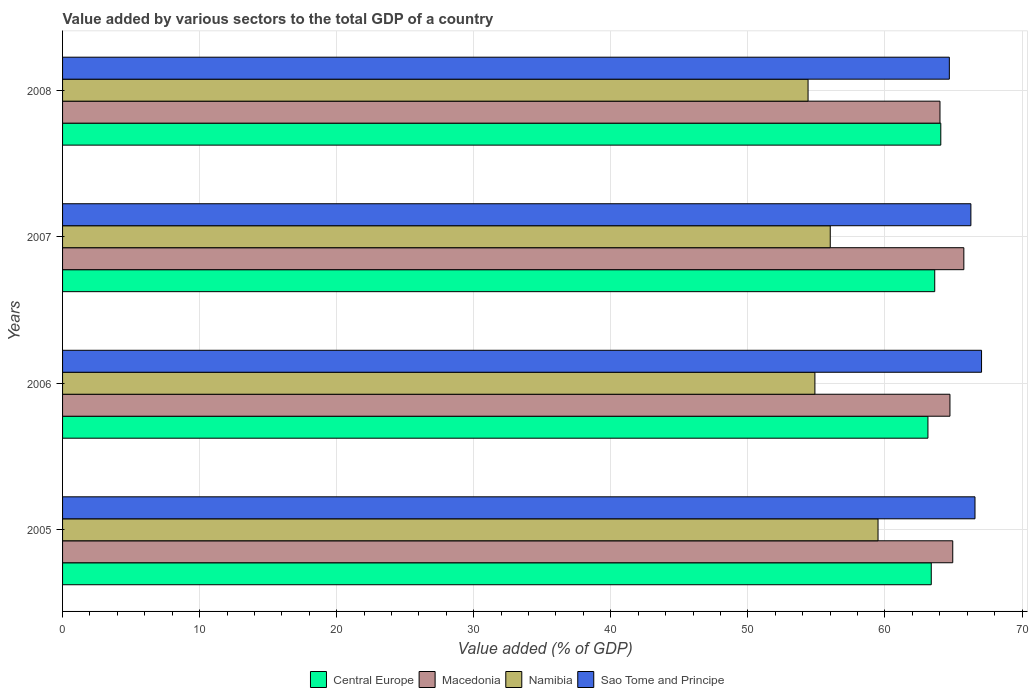Are the number of bars on each tick of the Y-axis equal?
Give a very brief answer. Yes. How many bars are there on the 1st tick from the top?
Your response must be concise. 4. How many bars are there on the 4th tick from the bottom?
Your response must be concise. 4. In how many cases, is the number of bars for a given year not equal to the number of legend labels?
Offer a very short reply. 0. What is the value added by various sectors to the total GDP in Namibia in 2006?
Offer a terse response. 54.89. Across all years, what is the maximum value added by various sectors to the total GDP in Sao Tome and Principe?
Give a very brief answer. 67.05. Across all years, what is the minimum value added by various sectors to the total GDP in Central Europe?
Your answer should be compact. 63.14. In which year was the value added by various sectors to the total GDP in Sao Tome and Principe maximum?
Offer a very short reply. 2006. In which year was the value added by various sectors to the total GDP in Sao Tome and Principe minimum?
Your answer should be compact. 2008. What is the total value added by various sectors to the total GDP in Namibia in the graph?
Make the answer very short. 224.79. What is the difference between the value added by various sectors to the total GDP in Sao Tome and Principe in 2006 and that in 2008?
Keep it short and to the point. 2.35. What is the difference between the value added by various sectors to the total GDP in Macedonia in 2006 and the value added by various sectors to the total GDP in Namibia in 2005?
Make the answer very short. 5.25. What is the average value added by various sectors to the total GDP in Macedonia per year?
Give a very brief answer. 64.87. In the year 2007, what is the difference between the value added by various sectors to the total GDP in Macedonia and value added by various sectors to the total GDP in Central Europe?
Your answer should be compact. 2.12. In how many years, is the value added by various sectors to the total GDP in Macedonia greater than 56 %?
Your response must be concise. 4. What is the ratio of the value added by various sectors to the total GDP in Namibia in 2005 to that in 2008?
Your answer should be very brief. 1.09. Is the value added by various sectors to the total GDP in Central Europe in 2005 less than that in 2007?
Provide a short and direct response. Yes. Is the difference between the value added by various sectors to the total GDP in Macedonia in 2005 and 2006 greater than the difference between the value added by various sectors to the total GDP in Central Europe in 2005 and 2006?
Give a very brief answer. No. What is the difference between the highest and the second highest value added by various sectors to the total GDP in Central Europe?
Your response must be concise. 0.44. What is the difference between the highest and the lowest value added by various sectors to the total GDP in Central Europe?
Your answer should be very brief. 0.94. In how many years, is the value added by various sectors to the total GDP in Macedonia greater than the average value added by various sectors to the total GDP in Macedonia taken over all years?
Provide a short and direct response. 2. Is the sum of the value added by various sectors to the total GDP in Sao Tome and Principe in 2005 and 2006 greater than the maximum value added by various sectors to the total GDP in Macedonia across all years?
Ensure brevity in your answer.  Yes. Is it the case that in every year, the sum of the value added by various sectors to the total GDP in Central Europe and value added by various sectors to the total GDP in Macedonia is greater than the sum of value added by various sectors to the total GDP in Sao Tome and Principe and value added by various sectors to the total GDP in Namibia?
Give a very brief answer. Yes. What does the 1st bar from the top in 2006 represents?
Ensure brevity in your answer.  Sao Tome and Principe. What does the 2nd bar from the bottom in 2006 represents?
Make the answer very short. Macedonia. How many bars are there?
Offer a terse response. 16. Are the values on the major ticks of X-axis written in scientific E-notation?
Ensure brevity in your answer.  No. Where does the legend appear in the graph?
Make the answer very short. Bottom center. How many legend labels are there?
Offer a very short reply. 4. What is the title of the graph?
Offer a very short reply. Value added by various sectors to the total GDP of a country. Does "Slovenia" appear as one of the legend labels in the graph?
Make the answer very short. No. What is the label or title of the X-axis?
Provide a short and direct response. Value added (% of GDP). What is the Value added (% of GDP) of Central Europe in 2005?
Your response must be concise. 63.38. What is the Value added (% of GDP) of Macedonia in 2005?
Your answer should be very brief. 64.95. What is the Value added (% of GDP) in Namibia in 2005?
Make the answer very short. 59.5. What is the Value added (% of GDP) in Sao Tome and Principe in 2005?
Offer a terse response. 66.57. What is the Value added (% of GDP) in Central Europe in 2006?
Ensure brevity in your answer.  63.14. What is the Value added (% of GDP) in Macedonia in 2006?
Offer a terse response. 64.74. What is the Value added (% of GDP) in Namibia in 2006?
Give a very brief answer. 54.89. What is the Value added (% of GDP) in Sao Tome and Principe in 2006?
Give a very brief answer. 67.05. What is the Value added (% of GDP) of Central Europe in 2007?
Your response must be concise. 63.63. What is the Value added (% of GDP) in Macedonia in 2007?
Make the answer very short. 65.76. What is the Value added (% of GDP) of Namibia in 2007?
Your answer should be compact. 56.01. What is the Value added (% of GDP) of Sao Tome and Principe in 2007?
Provide a succinct answer. 66.27. What is the Value added (% of GDP) in Central Europe in 2008?
Ensure brevity in your answer.  64.08. What is the Value added (% of GDP) of Macedonia in 2008?
Your answer should be very brief. 64.02. What is the Value added (% of GDP) of Namibia in 2008?
Offer a terse response. 54.39. What is the Value added (% of GDP) of Sao Tome and Principe in 2008?
Keep it short and to the point. 64.7. Across all years, what is the maximum Value added (% of GDP) of Central Europe?
Provide a succinct answer. 64.08. Across all years, what is the maximum Value added (% of GDP) in Macedonia?
Keep it short and to the point. 65.76. Across all years, what is the maximum Value added (% of GDP) of Namibia?
Keep it short and to the point. 59.5. Across all years, what is the maximum Value added (% of GDP) in Sao Tome and Principe?
Keep it short and to the point. 67.05. Across all years, what is the minimum Value added (% of GDP) of Central Europe?
Provide a short and direct response. 63.14. Across all years, what is the minimum Value added (% of GDP) in Macedonia?
Keep it short and to the point. 64.02. Across all years, what is the minimum Value added (% of GDP) of Namibia?
Ensure brevity in your answer.  54.39. Across all years, what is the minimum Value added (% of GDP) in Sao Tome and Principe?
Keep it short and to the point. 64.7. What is the total Value added (% of GDP) of Central Europe in the graph?
Keep it short and to the point. 254.22. What is the total Value added (% of GDP) of Macedonia in the graph?
Your response must be concise. 259.46. What is the total Value added (% of GDP) of Namibia in the graph?
Give a very brief answer. 224.79. What is the total Value added (% of GDP) in Sao Tome and Principe in the graph?
Offer a very short reply. 264.59. What is the difference between the Value added (% of GDP) of Central Europe in 2005 and that in 2006?
Provide a succinct answer. 0.24. What is the difference between the Value added (% of GDP) of Macedonia in 2005 and that in 2006?
Give a very brief answer. 0.2. What is the difference between the Value added (% of GDP) of Namibia in 2005 and that in 2006?
Your answer should be very brief. 4.6. What is the difference between the Value added (% of GDP) in Sao Tome and Principe in 2005 and that in 2006?
Your answer should be compact. -0.48. What is the difference between the Value added (% of GDP) of Central Europe in 2005 and that in 2007?
Your answer should be compact. -0.25. What is the difference between the Value added (% of GDP) in Macedonia in 2005 and that in 2007?
Offer a terse response. -0.81. What is the difference between the Value added (% of GDP) in Namibia in 2005 and that in 2007?
Ensure brevity in your answer.  3.49. What is the difference between the Value added (% of GDP) in Sao Tome and Principe in 2005 and that in 2007?
Your answer should be very brief. 0.3. What is the difference between the Value added (% of GDP) in Central Europe in 2005 and that in 2008?
Make the answer very short. -0.7. What is the difference between the Value added (% of GDP) of Macedonia in 2005 and that in 2008?
Give a very brief answer. 0.93. What is the difference between the Value added (% of GDP) of Namibia in 2005 and that in 2008?
Make the answer very short. 5.1. What is the difference between the Value added (% of GDP) in Sao Tome and Principe in 2005 and that in 2008?
Provide a succinct answer. 1.87. What is the difference between the Value added (% of GDP) of Central Europe in 2006 and that in 2007?
Keep it short and to the point. -0.5. What is the difference between the Value added (% of GDP) in Macedonia in 2006 and that in 2007?
Give a very brief answer. -1.01. What is the difference between the Value added (% of GDP) in Namibia in 2006 and that in 2007?
Your answer should be very brief. -1.12. What is the difference between the Value added (% of GDP) in Sao Tome and Principe in 2006 and that in 2007?
Keep it short and to the point. 0.78. What is the difference between the Value added (% of GDP) of Central Europe in 2006 and that in 2008?
Offer a very short reply. -0.94. What is the difference between the Value added (% of GDP) of Macedonia in 2006 and that in 2008?
Your answer should be compact. 0.73. What is the difference between the Value added (% of GDP) of Namibia in 2006 and that in 2008?
Offer a very short reply. 0.5. What is the difference between the Value added (% of GDP) in Sao Tome and Principe in 2006 and that in 2008?
Keep it short and to the point. 2.35. What is the difference between the Value added (% of GDP) of Central Europe in 2007 and that in 2008?
Make the answer very short. -0.44. What is the difference between the Value added (% of GDP) of Macedonia in 2007 and that in 2008?
Your response must be concise. 1.74. What is the difference between the Value added (% of GDP) in Namibia in 2007 and that in 2008?
Offer a terse response. 1.62. What is the difference between the Value added (% of GDP) in Sao Tome and Principe in 2007 and that in 2008?
Make the answer very short. 1.57. What is the difference between the Value added (% of GDP) of Central Europe in 2005 and the Value added (% of GDP) of Macedonia in 2006?
Ensure brevity in your answer.  -1.36. What is the difference between the Value added (% of GDP) in Central Europe in 2005 and the Value added (% of GDP) in Namibia in 2006?
Provide a succinct answer. 8.49. What is the difference between the Value added (% of GDP) of Central Europe in 2005 and the Value added (% of GDP) of Sao Tome and Principe in 2006?
Provide a short and direct response. -3.67. What is the difference between the Value added (% of GDP) of Macedonia in 2005 and the Value added (% of GDP) of Namibia in 2006?
Ensure brevity in your answer.  10.06. What is the difference between the Value added (% of GDP) in Macedonia in 2005 and the Value added (% of GDP) in Sao Tome and Principe in 2006?
Your answer should be compact. -2.1. What is the difference between the Value added (% of GDP) in Namibia in 2005 and the Value added (% of GDP) in Sao Tome and Principe in 2006?
Provide a short and direct response. -7.55. What is the difference between the Value added (% of GDP) in Central Europe in 2005 and the Value added (% of GDP) in Macedonia in 2007?
Offer a terse response. -2.38. What is the difference between the Value added (% of GDP) of Central Europe in 2005 and the Value added (% of GDP) of Namibia in 2007?
Provide a short and direct response. 7.37. What is the difference between the Value added (% of GDP) in Central Europe in 2005 and the Value added (% of GDP) in Sao Tome and Principe in 2007?
Give a very brief answer. -2.89. What is the difference between the Value added (% of GDP) of Macedonia in 2005 and the Value added (% of GDP) of Namibia in 2007?
Offer a very short reply. 8.94. What is the difference between the Value added (% of GDP) in Macedonia in 2005 and the Value added (% of GDP) in Sao Tome and Principe in 2007?
Your response must be concise. -1.32. What is the difference between the Value added (% of GDP) of Namibia in 2005 and the Value added (% of GDP) of Sao Tome and Principe in 2007?
Offer a terse response. -6.78. What is the difference between the Value added (% of GDP) in Central Europe in 2005 and the Value added (% of GDP) in Macedonia in 2008?
Your answer should be compact. -0.64. What is the difference between the Value added (% of GDP) of Central Europe in 2005 and the Value added (% of GDP) of Namibia in 2008?
Your response must be concise. 8.99. What is the difference between the Value added (% of GDP) of Central Europe in 2005 and the Value added (% of GDP) of Sao Tome and Principe in 2008?
Ensure brevity in your answer.  -1.32. What is the difference between the Value added (% of GDP) of Macedonia in 2005 and the Value added (% of GDP) of Namibia in 2008?
Provide a short and direct response. 10.56. What is the difference between the Value added (% of GDP) in Macedonia in 2005 and the Value added (% of GDP) in Sao Tome and Principe in 2008?
Provide a succinct answer. 0.25. What is the difference between the Value added (% of GDP) of Namibia in 2005 and the Value added (% of GDP) of Sao Tome and Principe in 2008?
Provide a succinct answer. -5.2. What is the difference between the Value added (% of GDP) of Central Europe in 2006 and the Value added (% of GDP) of Macedonia in 2007?
Offer a very short reply. -2.62. What is the difference between the Value added (% of GDP) of Central Europe in 2006 and the Value added (% of GDP) of Namibia in 2007?
Your response must be concise. 7.13. What is the difference between the Value added (% of GDP) of Central Europe in 2006 and the Value added (% of GDP) of Sao Tome and Principe in 2007?
Give a very brief answer. -3.13. What is the difference between the Value added (% of GDP) in Macedonia in 2006 and the Value added (% of GDP) in Namibia in 2007?
Give a very brief answer. 8.73. What is the difference between the Value added (% of GDP) of Macedonia in 2006 and the Value added (% of GDP) of Sao Tome and Principe in 2007?
Offer a terse response. -1.53. What is the difference between the Value added (% of GDP) of Namibia in 2006 and the Value added (% of GDP) of Sao Tome and Principe in 2007?
Your response must be concise. -11.38. What is the difference between the Value added (% of GDP) of Central Europe in 2006 and the Value added (% of GDP) of Macedonia in 2008?
Provide a short and direct response. -0.88. What is the difference between the Value added (% of GDP) in Central Europe in 2006 and the Value added (% of GDP) in Namibia in 2008?
Give a very brief answer. 8.75. What is the difference between the Value added (% of GDP) in Central Europe in 2006 and the Value added (% of GDP) in Sao Tome and Principe in 2008?
Offer a very short reply. -1.56. What is the difference between the Value added (% of GDP) in Macedonia in 2006 and the Value added (% of GDP) in Namibia in 2008?
Provide a short and direct response. 10.35. What is the difference between the Value added (% of GDP) of Macedonia in 2006 and the Value added (% of GDP) of Sao Tome and Principe in 2008?
Your answer should be very brief. 0.04. What is the difference between the Value added (% of GDP) of Namibia in 2006 and the Value added (% of GDP) of Sao Tome and Principe in 2008?
Offer a terse response. -9.81. What is the difference between the Value added (% of GDP) in Central Europe in 2007 and the Value added (% of GDP) in Macedonia in 2008?
Your answer should be compact. -0.38. What is the difference between the Value added (% of GDP) of Central Europe in 2007 and the Value added (% of GDP) of Namibia in 2008?
Provide a short and direct response. 9.24. What is the difference between the Value added (% of GDP) of Central Europe in 2007 and the Value added (% of GDP) of Sao Tome and Principe in 2008?
Provide a succinct answer. -1.07. What is the difference between the Value added (% of GDP) of Macedonia in 2007 and the Value added (% of GDP) of Namibia in 2008?
Provide a short and direct response. 11.37. What is the difference between the Value added (% of GDP) of Macedonia in 2007 and the Value added (% of GDP) of Sao Tome and Principe in 2008?
Ensure brevity in your answer.  1.06. What is the difference between the Value added (% of GDP) in Namibia in 2007 and the Value added (% of GDP) in Sao Tome and Principe in 2008?
Keep it short and to the point. -8.69. What is the average Value added (% of GDP) of Central Europe per year?
Keep it short and to the point. 63.56. What is the average Value added (% of GDP) of Macedonia per year?
Your answer should be compact. 64.87. What is the average Value added (% of GDP) in Namibia per year?
Keep it short and to the point. 56.2. What is the average Value added (% of GDP) in Sao Tome and Principe per year?
Offer a terse response. 66.15. In the year 2005, what is the difference between the Value added (% of GDP) in Central Europe and Value added (% of GDP) in Macedonia?
Provide a short and direct response. -1.57. In the year 2005, what is the difference between the Value added (% of GDP) of Central Europe and Value added (% of GDP) of Namibia?
Your response must be concise. 3.88. In the year 2005, what is the difference between the Value added (% of GDP) of Central Europe and Value added (% of GDP) of Sao Tome and Principe?
Provide a succinct answer. -3.19. In the year 2005, what is the difference between the Value added (% of GDP) of Macedonia and Value added (% of GDP) of Namibia?
Provide a succinct answer. 5.45. In the year 2005, what is the difference between the Value added (% of GDP) of Macedonia and Value added (% of GDP) of Sao Tome and Principe?
Keep it short and to the point. -1.62. In the year 2005, what is the difference between the Value added (% of GDP) of Namibia and Value added (% of GDP) of Sao Tome and Principe?
Your answer should be very brief. -7.08. In the year 2006, what is the difference between the Value added (% of GDP) of Central Europe and Value added (% of GDP) of Macedonia?
Ensure brevity in your answer.  -1.61. In the year 2006, what is the difference between the Value added (% of GDP) of Central Europe and Value added (% of GDP) of Namibia?
Your answer should be compact. 8.25. In the year 2006, what is the difference between the Value added (% of GDP) in Central Europe and Value added (% of GDP) in Sao Tome and Principe?
Make the answer very short. -3.91. In the year 2006, what is the difference between the Value added (% of GDP) of Macedonia and Value added (% of GDP) of Namibia?
Your answer should be compact. 9.85. In the year 2006, what is the difference between the Value added (% of GDP) in Macedonia and Value added (% of GDP) in Sao Tome and Principe?
Your answer should be compact. -2.31. In the year 2006, what is the difference between the Value added (% of GDP) in Namibia and Value added (% of GDP) in Sao Tome and Principe?
Keep it short and to the point. -12.16. In the year 2007, what is the difference between the Value added (% of GDP) of Central Europe and Value added (% of GDP) of Macedonia?
Your answer should be compact. -2.12. In the year 2007, what is the difference between the Value added (% of GDP) in Central Europe and Value added (% of GDP) in Namibia?
Provide a succinct answer. 7.62. In the year 2007, what is the difference between the Value added (% of GDP) in Central Europe and Value added (% of GDP) in Sao Tome and Principe?
Provide a short and direct response. -2.64. In the year 2007, what is the difference between the Value added (% of GDP) of Macedonia and Value added (% of GDP) of Namibia?
Ensure brevity in your answer.  9.75. In the year 2007, what is the difference between the Value added (% of GDP) in Macedonia and Value added (% of GDP) in Sao Tome and Principe?
Provide a succinct answer. -0.51. In the year 2007, what is the difference between the Value added (% of GDP) of Namibia and Value added (% of GDP) of Sao Tome and Principe?
Provide a succinct answer. -10.26. In the year 2008, what is the difference between the Value added (% of GDP) of Central Europe and Value added (% of GDP) of Macedonia?
Provide a short and direct response. 0.06. In the year 2008, what is the difference between the Value added (% of GDP) of Central Europe and Value added (% of GDP) of Namibia?
Provide a succinct answer. 9.68. In the year 2008, what is the difference between the Value added (% of GDP) in Central Europe and Value added (% of GDP) in Sao Tome and Principe?
Offer a terse response. -0.62. In the year 2008, what is the difference between the Value added (% of GDP) of Macedonia and Value added (% of GDP) of Namibia?
Offer a very short reply. 9.62. In the year 2008, what is the difference between the Value added (% of GDP) of Macedonia and Value added (% of GDP) of Sao Tome and Principe?
Give a very brief answer. -0.68. In the year 2008, what is the difference between the Value added (% of GDP) in Namibia and Value added (% of GDP) in Sao Tome and Principe?
Ensure brevity in your answer.  -10.31. What is the ratio of the Value added (% of GDP) of Central Europe in 2005 to that in 2006?
Make the answer very short. 1. What is the ratio of the Value added (% of GDP) in Namibia in 2005 to that in 2006?
Provide a short and direct response. 1.08. What is the ratio of the Value added (% of GDP) of Sao Tome and Principe in 2005 to that in 2006?
Provide a short and direct response. 0.99. What is the ratio of the Value added (% of GDP) in Central Europe in 2005 to that in 2007?
Offer a very short reply. 1. What is the ratio of the Value added (% of GDP) of Macedonia in 2005 to that in 2007?
Keep it short and to the point. 0.99. What is the ratio of the Value added (% of GDP) of Namibia in 2005 to that in 2007?
Your answer should be very brief. 1.06. What is the ratio of the Value added (% of GDP) in Sao Tome and Principe in 2005 to that in 2007?
Provide a short and direct response. 1. What is the ratio of the Value added (% of GDP) in Macedonia in 2005 to that in 2008?
Your answer should be compact. 1.01. What is the ratio of the Value added (% of GDP) in Namibia in 2005 to that in 2008?
Offer a very short reply. 1.09. What is the ratio of the Value added (% of GDP) of Sao Tome and Principe in 2005 to that in 2008?
Ensure brevity in your answer.  1.03. What is the ratio of the Value added (% of GDP) of Macedonia in 2006 to that in 2007?
Ensure brevity in your answer.  0.98. What is the ratio of the Value added (% of GDP) in Namibia in 2006 to that in 2007?
Make the answer very short. 0.98. What is the ratio of the Value added (% of GDP) of Sao Tome and Principe in 2006 to that in 2007?
Your answer should be very brief. 1.01. What is the ratio of the Value added (% of GDP) in Central Europe in 2006 to that in 2008?
Ensure brevity in your answer.  0.99. What is the ratio of the Value added (% of GDP) of Macedonia in 2006 to that in 2008?
Ensure brevity in your answer.  1.01. What is the ratio of the Value added (% of GDP) in Namibia in 2006 to that in 2008?
Your answer should be very brief. 1.01. What is the ratio of the Value added (% of GDP) of Sao Tome and Principe in 2006 to that in 2008?
Make the answer very short. 1.04. What is the ratio of the Value added (% of GDP) of Macedonia in 2007 to that in 2008?
Your answer should be compact. 1.03. What is the ratio of the Value added (% of GDP) of Namibia in 2007 to that in 2008?
Your answer should be compact. 1.03. What is the ratio of the Value added (% of GDP) in Sao Tome and Principe in 2007 to that in 2008?
Keep it short and to the point. 1.02. What is the difference between the highest and the second highest Value added (% of GDP) in Central Europe?
Give a very brief answer. 0.44. What is the difference between the highest and the second highest Value added (% of GDP) of Macedonia?
Offer a terse response. 0.81. What is the difference between the highest and the second highest Value added (% of GDP) of Namibia?
Offer a terse response. 3.49. What is the difference between the highest and the second highest Value added (% of GDP) in Sao Tome and Principe?
Give a very brief answer. 0.48. What is the difference between the highest and the lowest Value added (% of GDP) in Central Europe?
Ensure brevity in your answer.  0.94. What is the difference between the highest and the lowest Value added (% of GDP) of Macedonia?
Provide a succinct answer. 1.74. What is the difference between the highest and the lowest Value added (% of GDP) of Namibia?
Offer a very short reply. 5.1. What is the difference between the highest and the lowest Value added (% of GDP) in Sao Tome and Principe?
Your response must be concise. 2.35. 